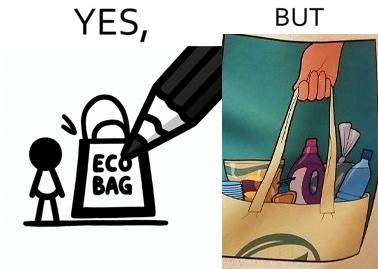Compare the left and right sides of this image. In the left part of the image: A picture of a bag with eco bag written on it. In the right part of the image: The image of the material that is kept in the bag. 